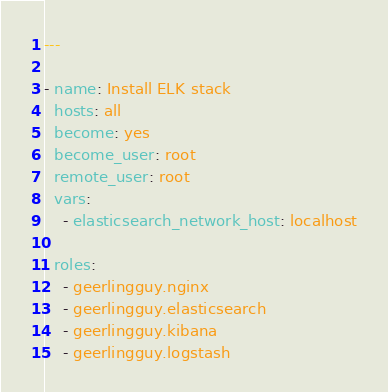<code> <loc_0><loc_0><loc_500><loc_500><_YAML_>---

- name: Install ELK stack
  hosts: all
  become: yes
  become_user: root
  remote_user: root
  vars:
    - elasticsearch_network_host: localhost

  roles:
    - geerlingguy.nginx
    - geerlingguy.elasticsearch
    - geerlingguy.kibana
    - geerlingguy.logstash
</code> 